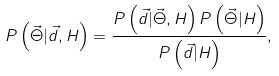<formula> <loc_0><loc_0><loc_500><loc_500>P \left ( \vec { \Theta } | \vec { d } , H \right ) = \frac { P \left ( \vec { d } | \vec { \Theta } , H \right ) P \left ( \vec { \Theta } | H \right ) } { P \left ( \vec { d } | H \right ) } ,</formula> 